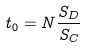Convert formula to latex. <formula><loc_0><loc_0><loc_500><loc_500>t _ { 0 } = N \frac { S _ { D } } { S _ { C } }</formula> 